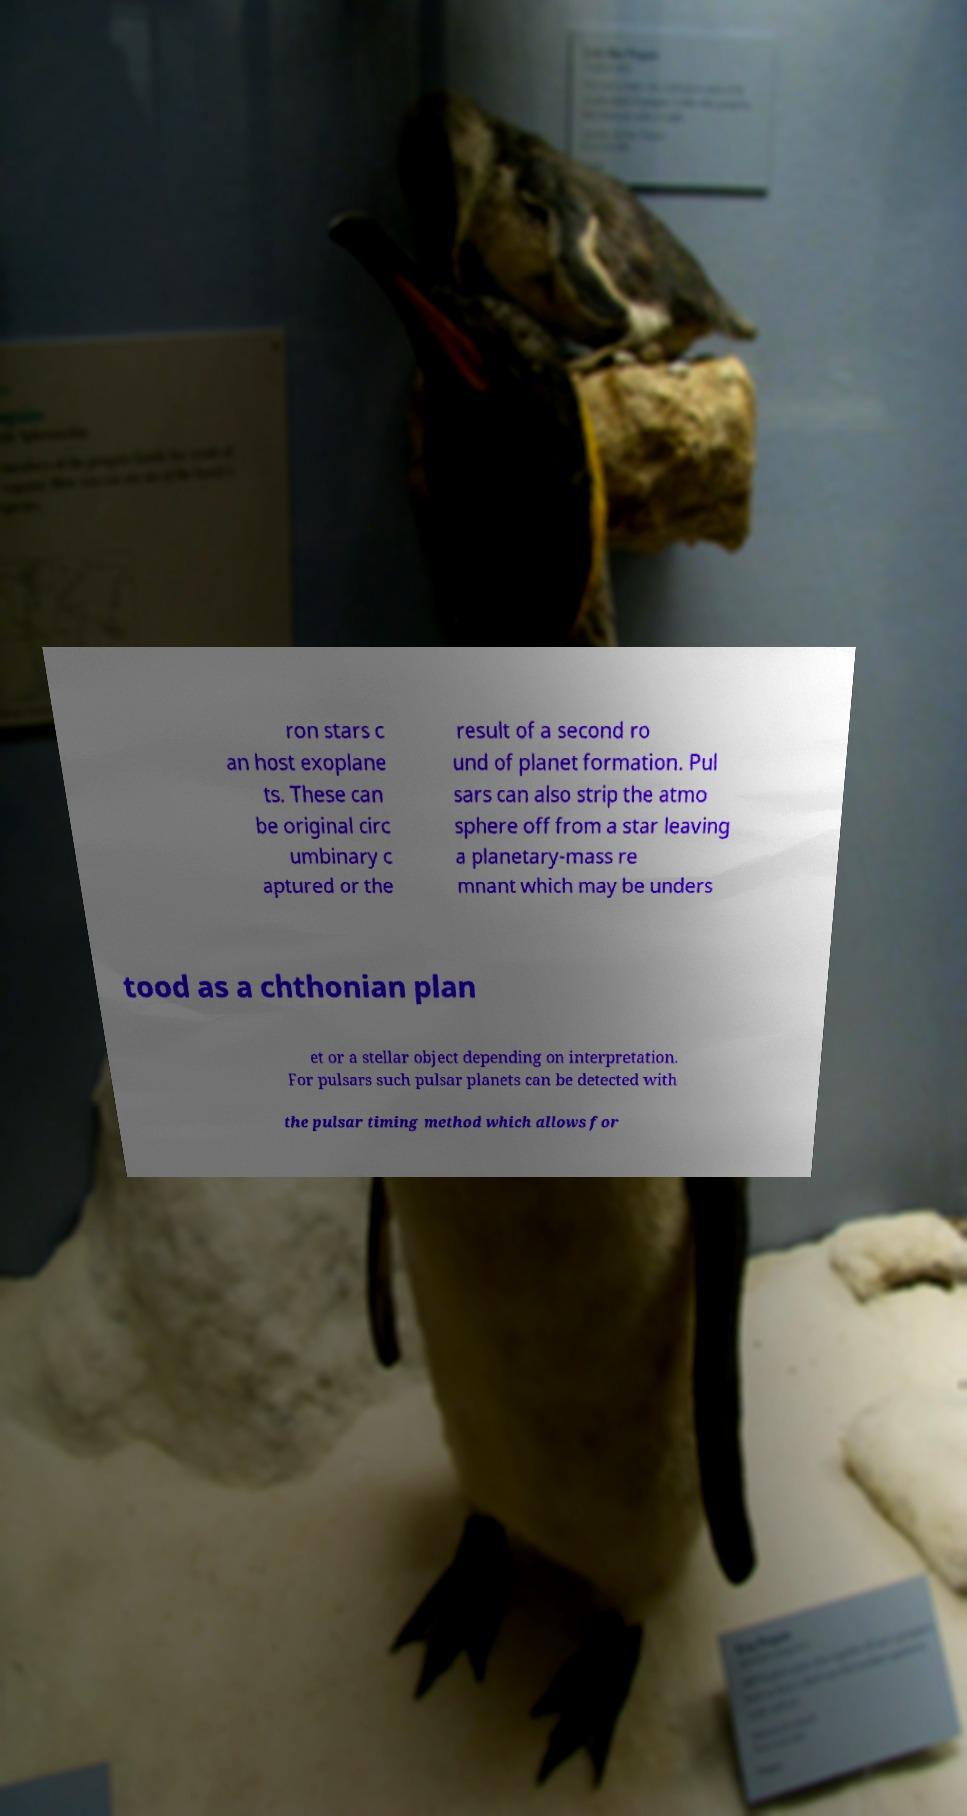There's text embedded in this image that I need extracted. Can you transcribe it verbatim? ron stars c an host exoplane ts. These can be original circ umbinary c aptured or the result of a second ro und of planet formation. Pul sars can also strip the atmo sphere off from a star leaving a planetary-mass re mnant which may be unders tood as a chthonian plan et or a stellar object depending on interpretation. For pulsars such pulsar planets can be detected with the pulsar timing method which allows for 